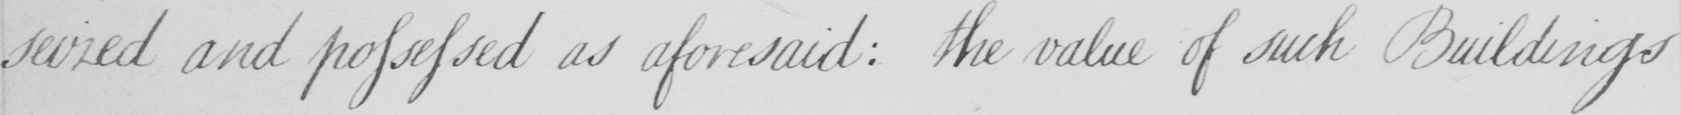Transcribe the text shown in this historical manuscript line. seized and possessed as aforesaid :  the value of such Buildings 